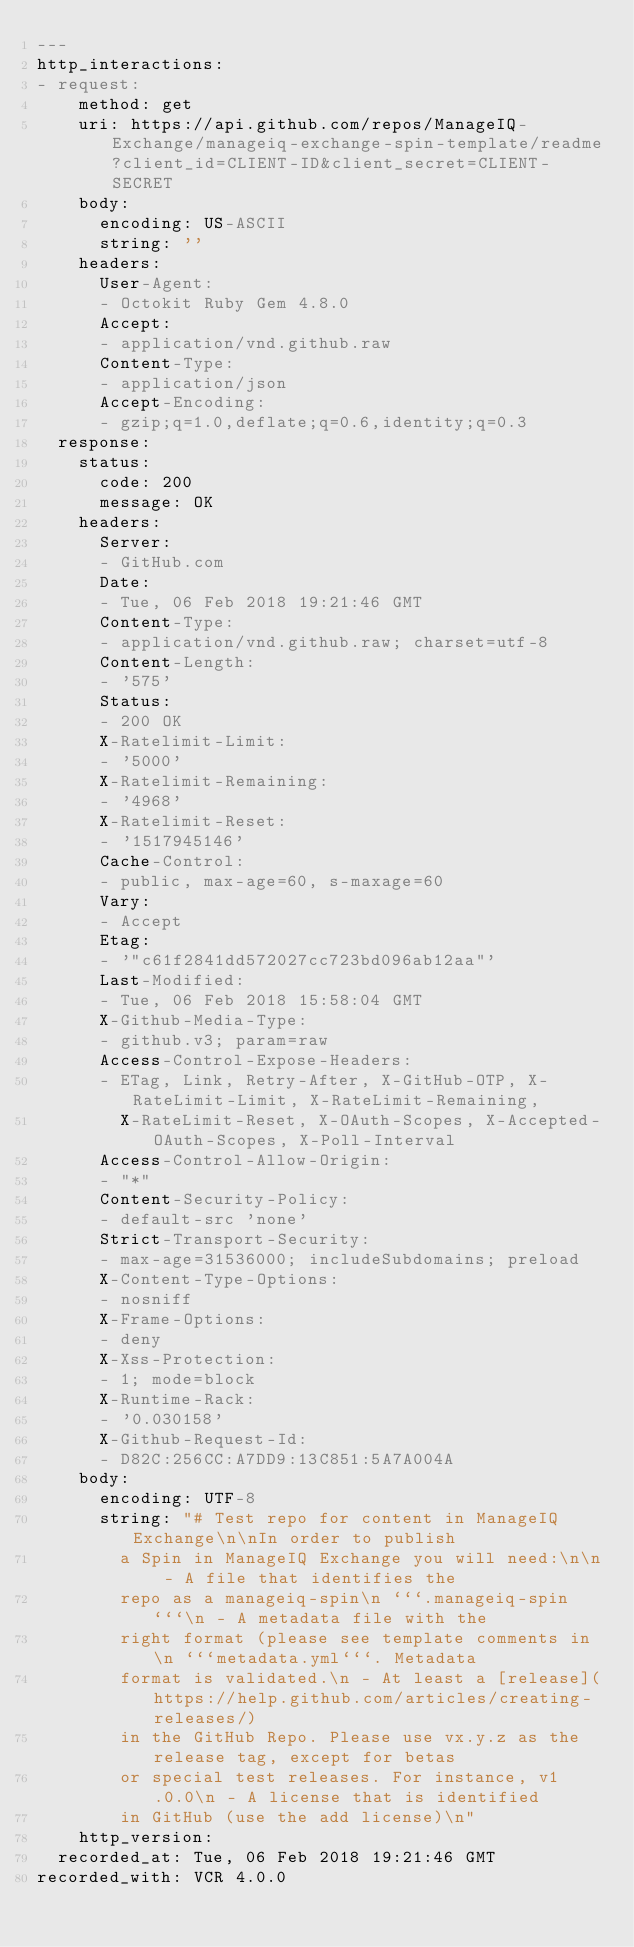<code> <loc_0><loc_0><loc_500><loc_500><_YAML_>---
http_interactions:
- request:
    method: get
    uri: https://api.github.com/repos/ManageIQ-Exchange/manageiq-exchange-spin-template/readme?client_id=CLIENT-ID&client_secret=CLIENT-SECRET
    body:
      encoding: US-ASCII
      string: ''
    headers:
      User-Agent:
      - Octokit Ruby Gem 4.8.0
      Accept:
      - application/vnd.github.raw
      Content-Type:
      - application/json
      Accept-Encoding:
      - gzip;q=1.0,deflate;q=0.6,identity;q=0.3
  response:
    status:
      code: 200
      message: OK
    headers:
      Server:
      - GitHub.com
      Date:
      - Tue, 06 Feb 2018 19:21:46 GMT
      Content-Type:
      - application/vnd.github.raw; charset=utf-8
      Content-Length:
      - '575'
      Status:
      - 200 OK
      X-Ratelimit-Limit:
      - '5000'
      X-Ratelimit-Remaining:
      - '4968'
      X-Ratelimit-Reset:
      - '1517945146'
      Cache-Control:
      - public, max-age=60, s-maxage=60
      Vary:
      - Accept
      Etag:
      - '"c61f2841dd572027cc723bd096ab12aa"'
      Last-Modified:
      - Tue, 06 Feb 2018 15:58:04 GMT
      X-Github-Media-Type:
      - github.v3; param=raw
      Access-Control-Expose-Headers:
      - ETag, Link, Retry-After, X-GitHub-OTP, X-RateLimit-Limit, X-RateLimit-Remaining,
        X-RateLimit-Reset, X-OAuth-Scopes, X-Accepted-OAuth-Scopes, X-Poll-Interval
      Access-Control-Allow-Origin:
      - "*"
      Content-Security-Policy:
      - default-src 'none'
      Strict-Transport-Security:
      - max-age=31536000; includeSubdomains; preload
      X-Content-Type-Options:
      - nosniff
      X-Frame-Options:
      - deny
      X-Xss-Protection:
      - 1; mode=block
      X-Runtime-Rack:
      - '0.030158'
      X-Github-Request-Id:
      - D82C:256CC:A7DD9:13C851:5A7A004A
    body:
      encoding: UTF-8
      string: "# Test repo for content in ManageIQ Exchange\n\nIn order to publish
        a Spin in ManageIQ Exchange you will need:\n\n - A file that identifies the
        repo as a manageiq-spin\n ```.manageiq-spin```\n - A metadata file with the
        right format (please see template comments in \n ```metadata.yml```. Metadata
        format is validated.\n - At least a [release](https://help.github.com/articles/creating-releases/)
        in the GitHub Repo. Please use vx.y.z as the release tag, except for betas
        or special test releases. For instance, v1.0.0\n - A license that is identified
        in GitHub (use the add license)\n"
    http_version: 
  recorded_at: Tue, 06 Feb 2018 19:21:46 GMT
recorded_with: VCR 4.0.0
</code> 